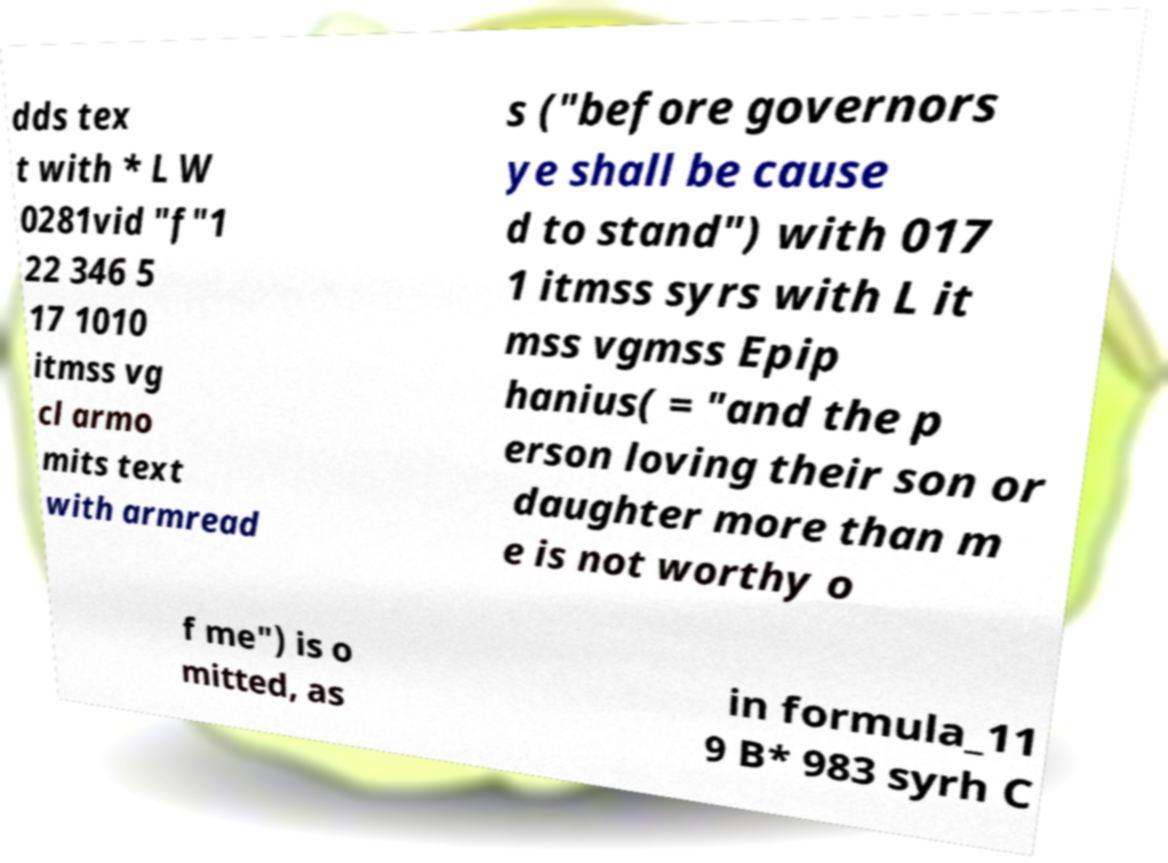Could you extract and type out the text from this image? dds tex t with * L W 0281vid "f"1 22 346 5 17 1010 itmss vg cl armo mits text with armread s ("before governors ye shall be cause d to stand") with 017 1 itmss syrs with L it mss vgmss Epip hanius( = "and the p erson loving their son or daughter more than m e is not worthy o f me") is o mitted, as in formula_11 9 B* 983 syrh C 